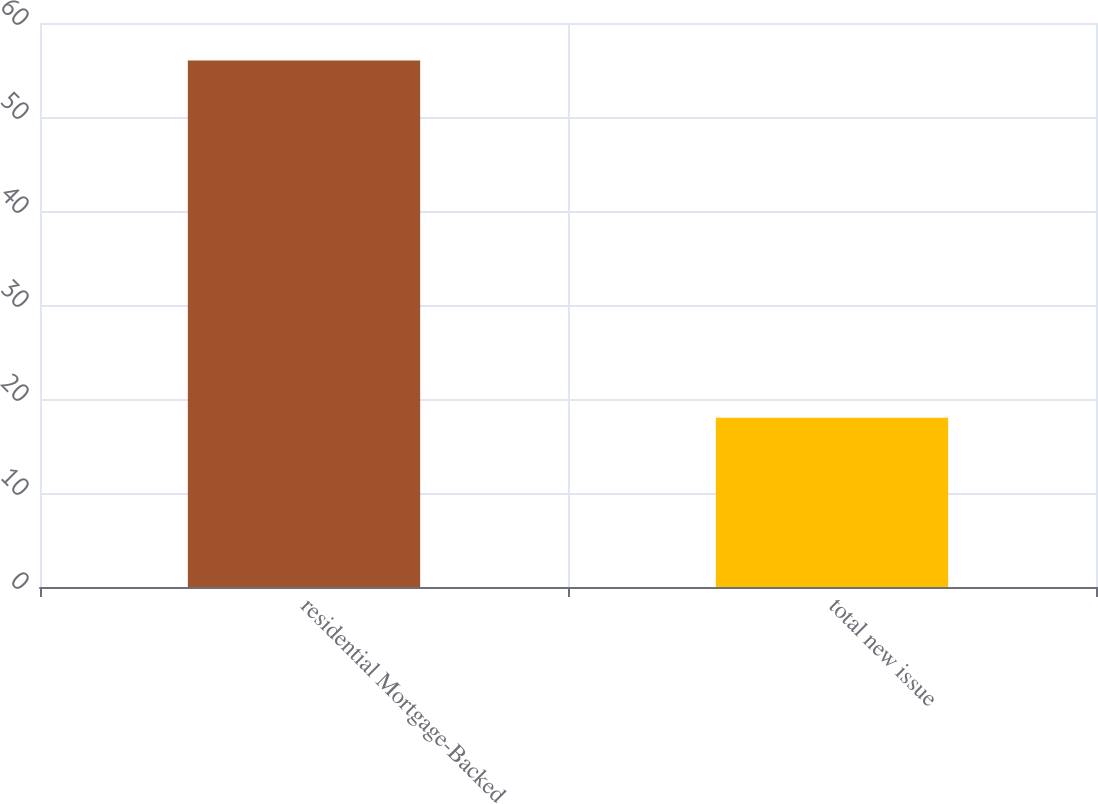<chart> <loc_0><loc_0><loc_500><loc_500><bar_chart><fcel>residential Mortgage-Backed<fcel>total new issue<nl><fcel>56<fcel>18<nl></chart> 